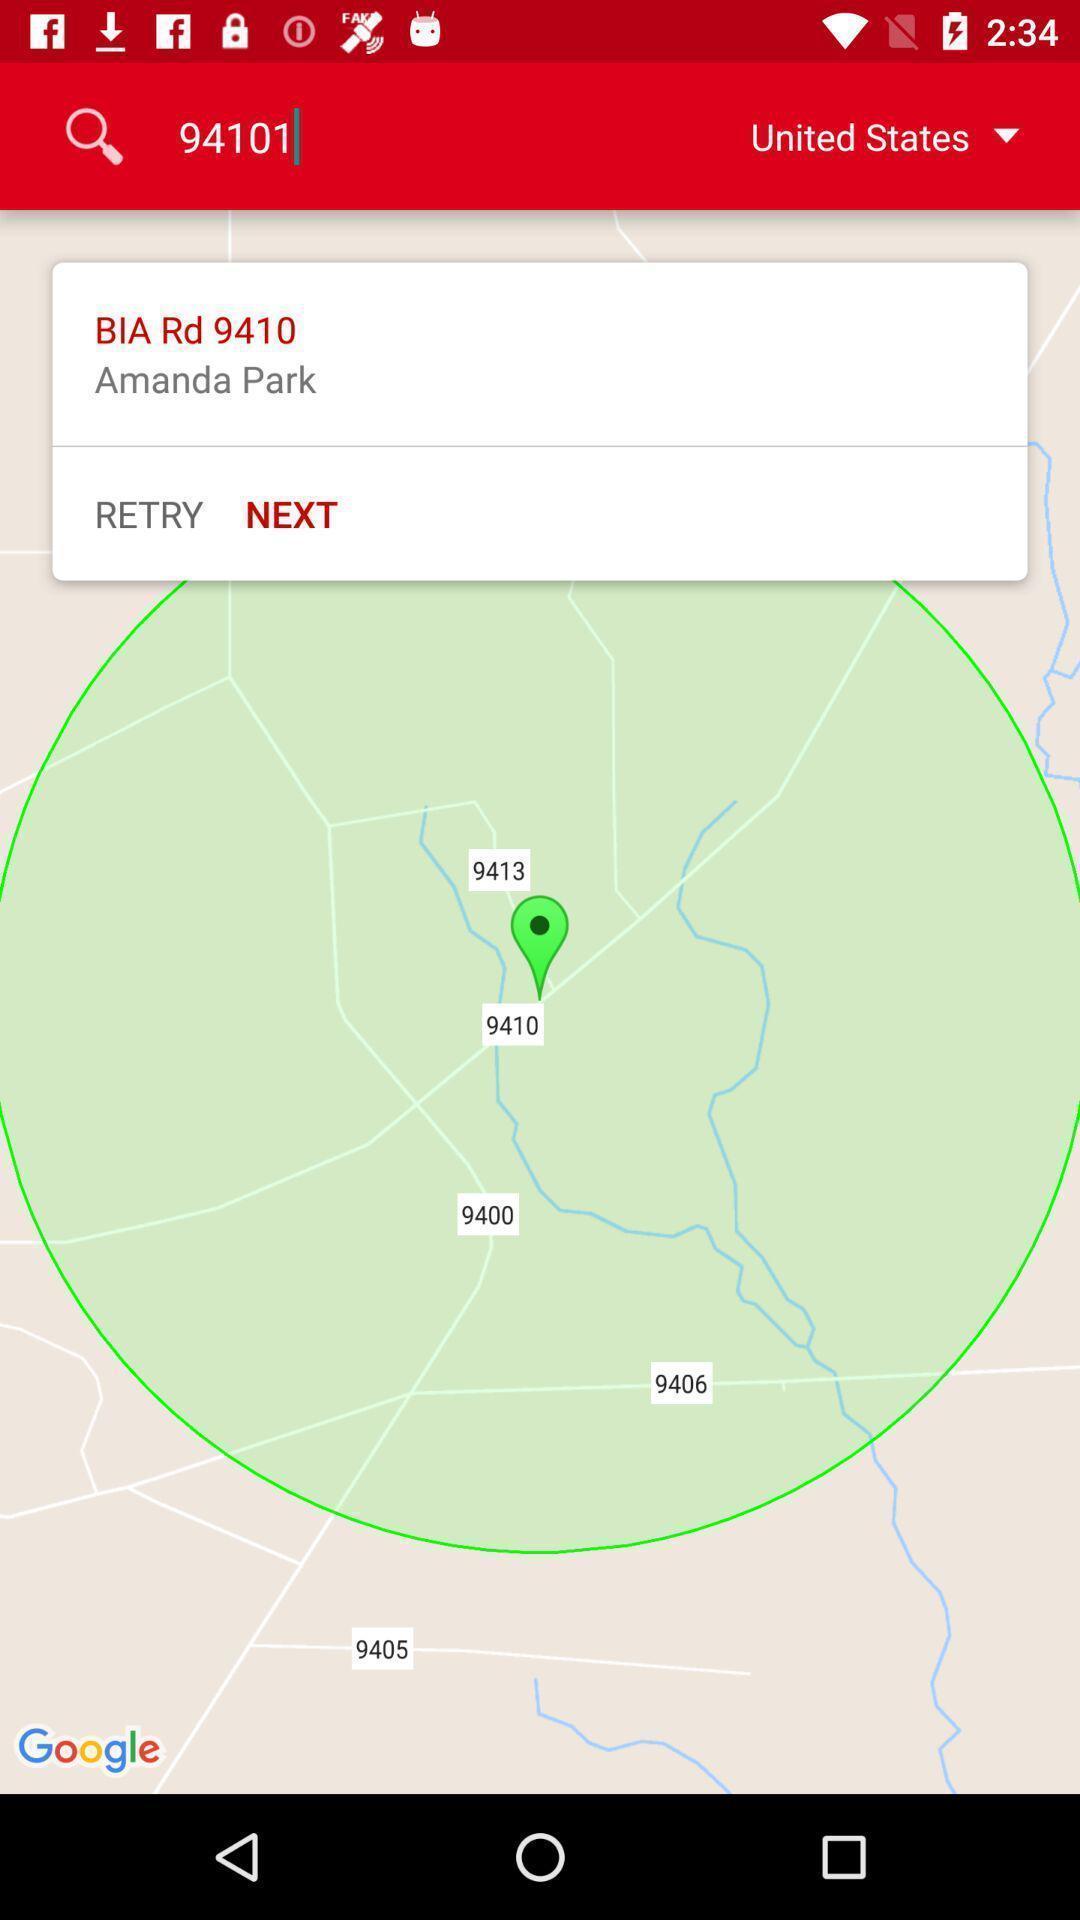Tell me about the visual elements in this screen capture. Screen displaying map view of a location. 